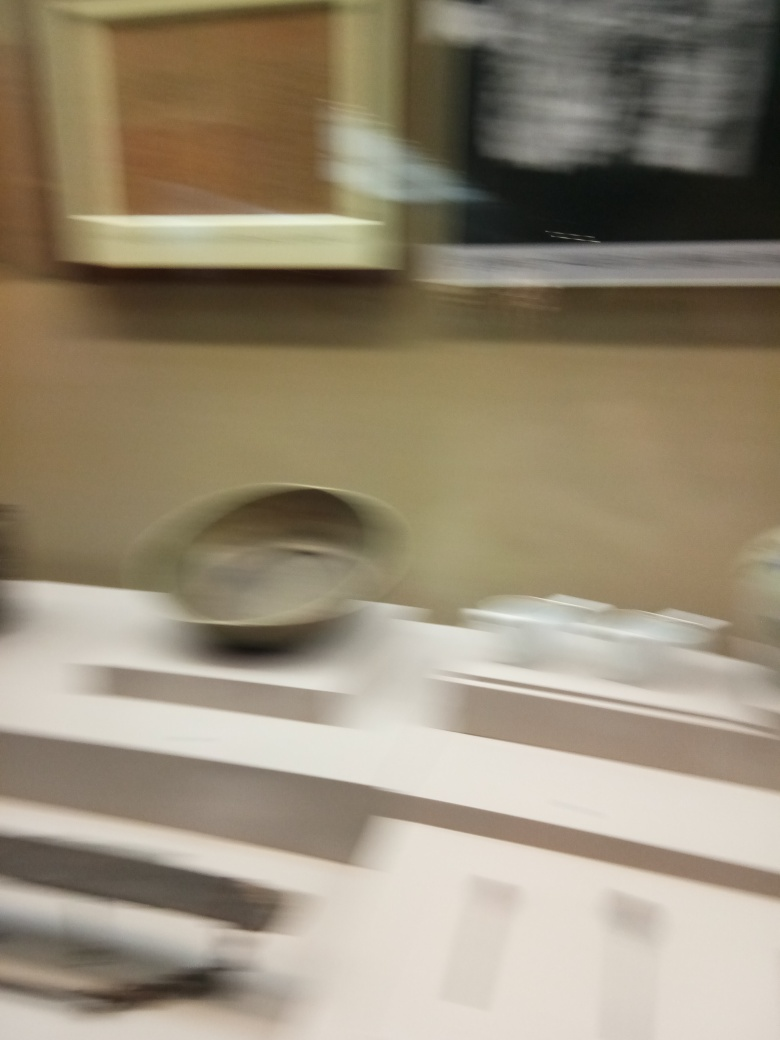Can you describe what might have caused the blur in this image? The blur in the image likely results from camera movement during the exposure. It could also be due to capturing a fast-moving object with a slow shutter speed, causing a motion blur effect where the moving subjects are smeared along the direction of movement. 